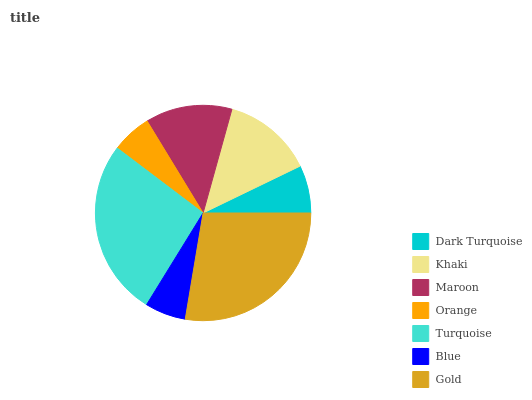Is Orange the minimum?
Answer yes or no. Yes. Is Gold the maximum?
Answer yes or no. Yes. Is Khaki the minimum?
Answer yes or no. No. Is Khaki the maximum?
Answer yes or no. No. Is Khaki greater than Dark Turquoise?
Answer yes or no. Yes. Is Dark Turquoise less than Khaki?
Answer yes or no. Yes. Is Dark Turquoise greater than Khaki?
Answer yes or no. No. Is Khaki less than Dark Turquoise?
Answer yes or no. No. Is Maroon the high median?
Answer yes or no. Yes. Is Maroon the low median?
Answer yes or no. Yes. Is Blue the high median?
Answer yes or no. No. Is Turquoise the low median?
Answer yes or no. No. 